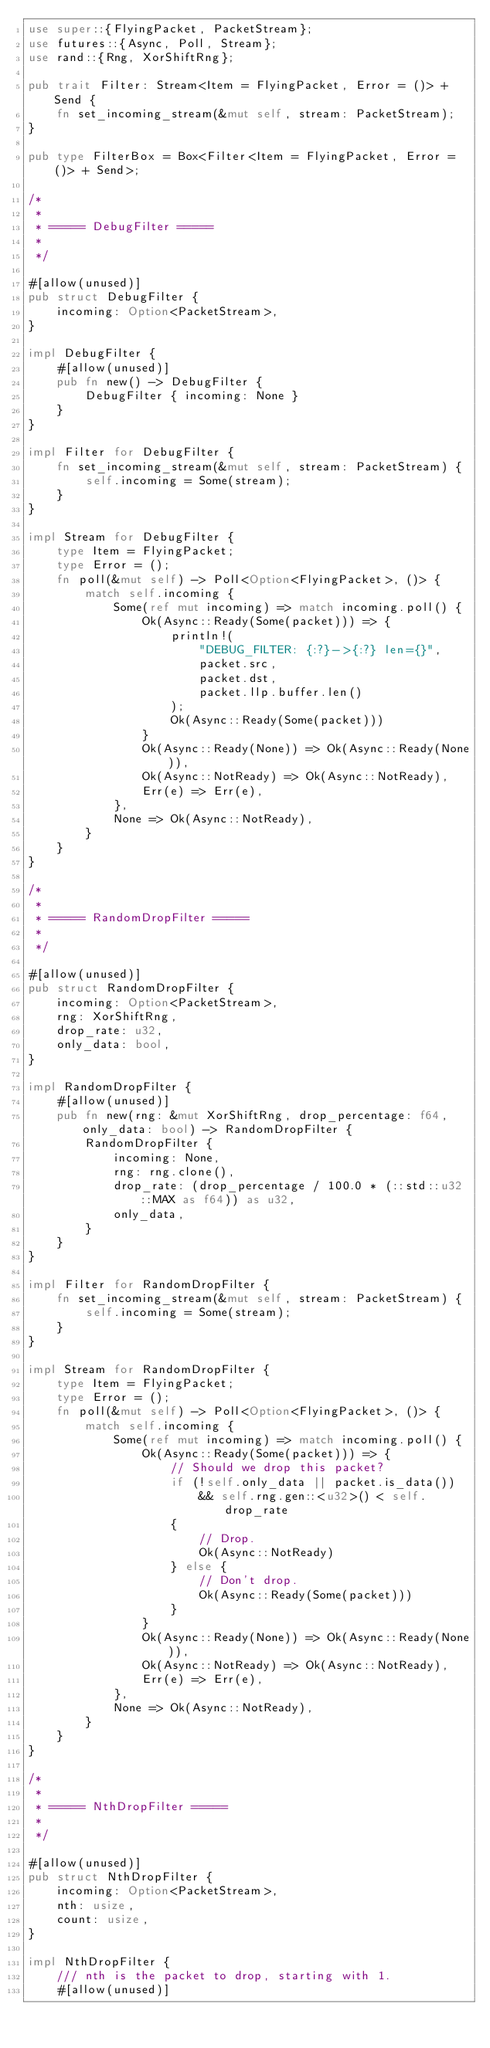Convert code to text. <code><loc_0><loc_0><loc_500><loc_500><_Rust_>use super::{FlyingPacket, PacketStream};
use futures::{Async, Poll, Stream};
use rand::{Rng, XorShiftRng};

pub trait Filter: Stream<Item = FlyingPacket, Error = ()> + Send {
    fn set_incoming_stream(&mut self, stream: PacketStream);
}

pub type FilterBox = Box<Filter<Item = FlyingPacket, Error = ()> + Send>;

/*
 *
 * ===== DebugFilter =====
 *
 */

#[allow(unused)]
pub struct DebugFilter {
    incoming: Option<PacketStream>,
}

impl DebugFilter {
    #[allow(unused)]
    pub fn new() -> DebugFilter {
        DebugFilter { incoming: None }
    }
}

impl Filter for DebugFilter {
    fn set_incoming_stream(&mut self, stream: PacketStream) {
        self.incoming = Some(stream);
    }
}

impl Stream for DebugFilter {
    type Item = FlyingPacket;
    type Error = ();
    fn poll(&mut self) -> Poll<Option<FlyingPacket>, ()> {
        match self.incoming {
            Some(ref mut incoming) => match incoming.poll() {
                Ok(Async::Ready(Some(packet))) => {
                    println!(
                        "DEBUG_FILTER: {:?}->{:?} len={}",
                        packet.src,
                        packet.dst,
                        packet.llp.buffer.len()
                    );
                    Ok(Async::Ready(Some(packet)))
                }
                Ok(Async::Ready(None)) => Ok(Async::Ready(None)),
                Ok(Async::NotReady) => Ok(Async::NotReady),
                Err(e) => Err(e),
            },
            None => Ok(Async::NotReady),
        }
    }
}

/*
 *
 * ===== RandomDropFilter =====
 *
 */

#[allow(unused)]
pub struct RandomDropFilter {
    incoming: Option<PacketStream>,
    rng: XorShiftRng,
    drop_rate: u32,
    only_data: bool,
}

impl RandomDropFilter {
    #[allow(unused)]
    pub fn new(rng: &mut XorShiftRng, drop_percentage: f64, only_data: bool) -> RandomDropFilter {
        RandomDropFilter {
            incoming: None,
            rng: rng.clone(),
            drop_rate: (drop_percentage / 100.0 * (::std::u32::MAX as f64)) as u32,
            only_data,
        }
    }
}

impl Filter for RandomDropFilter {
    fn set_incoming_stream(&mut self, stream: PacketStream) {
        self.incoming = Some(stream);
    }
}

impl Stream for RandomDropFilter {
    type Item = FlyingPacket;
    type Error = ();
    fn poll(&mut self) -> Poll<Option<FlyingPacket>, ()> {
        match self.incoming {
            Some(ref mut incoming) => match incoming.poll() {
                Ok(Async::Ready(Some(packet))) => {
                    // Should we drop this packet?
                    if (!self.only_data || packet.is_data())
                        && self.rng.gen::<u32>() < self.drop_rate
                    {
                        // Drop.
                        Ok(Async::NotReady)
                    } else {
                        // Don't drop.
                        Ok(Async::Ready(Some(packet)))
                    }
                }
                Ok(Async::Ready(None)) => Ok(Async::Ready(None)),
                Ok(Async::NotReady) => Ok(Async::NotReady),
                Err(e) => Err(e),
            },
            None => Ok(Async::NotReady),
        }
    }
}

/*
 *
 * ===== NthDropFilter =====
 *
 */

#[allow(unused)]
pub struct NthDropFilter {
    incoming: Option<PacketStream>,
    nth: usize,
    count: usize,
}

impl NthDropFilter {
    /// nth is the packet to drop, starting with 1.
    #[allow(unused)]</code> 